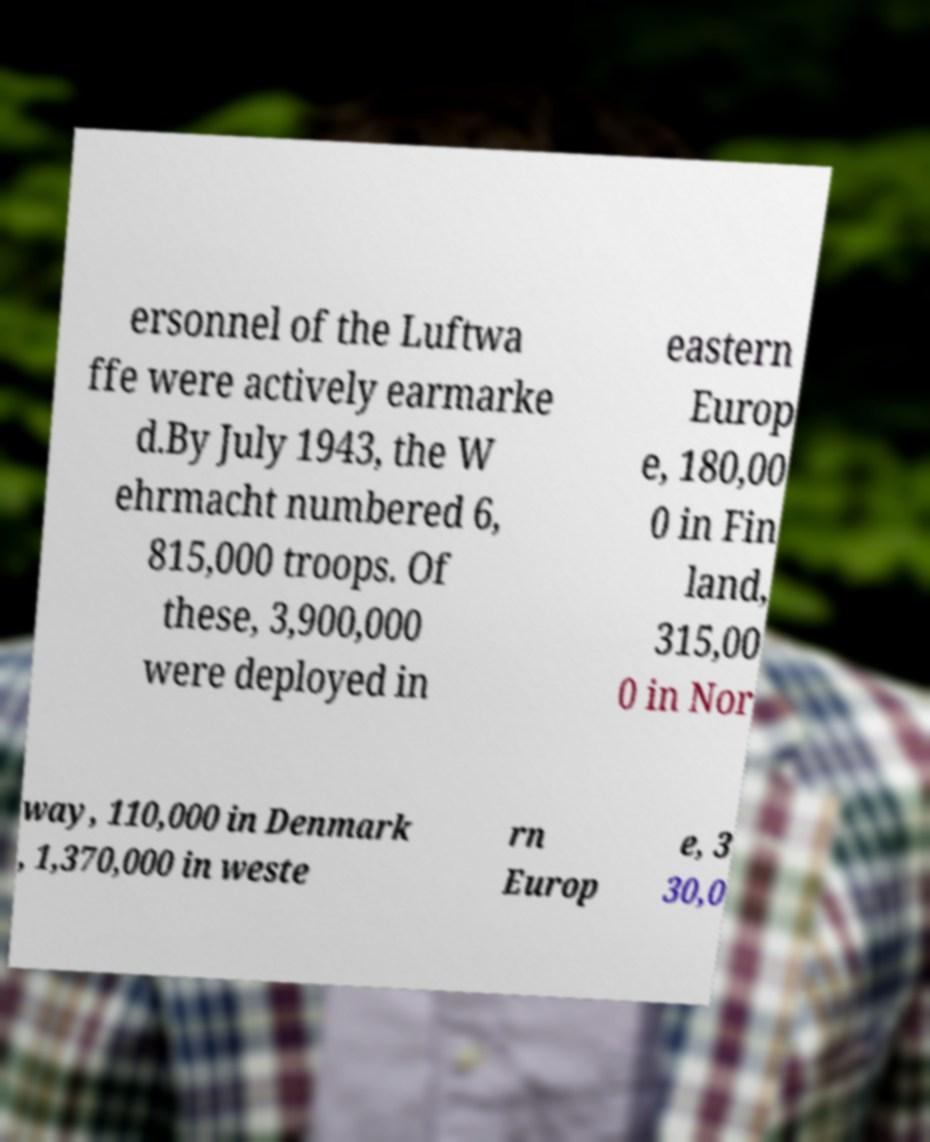There's text embedded in this image that I need extracted. Can you transcribe it verbatim? ersonnel of the Luftwa ffe were actively earmarke d.By July 1943, the W ehrmacht numbered 6, 815,000 troops. Of these, 3,900,000 were deployed in eastern Europ e, 180,00 0 in Fin land, 315,00 0 in Nor way, 110,000 in Denmark , 1,370,000 in weste rn Europ e, 3 30,0 